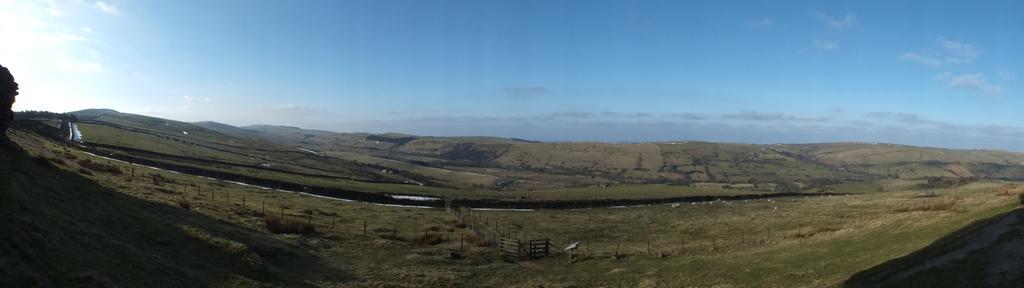Can you describe this image briefly? In the picture I can see grasslands, wooden fence and the blue color sky with clouds in the background. 